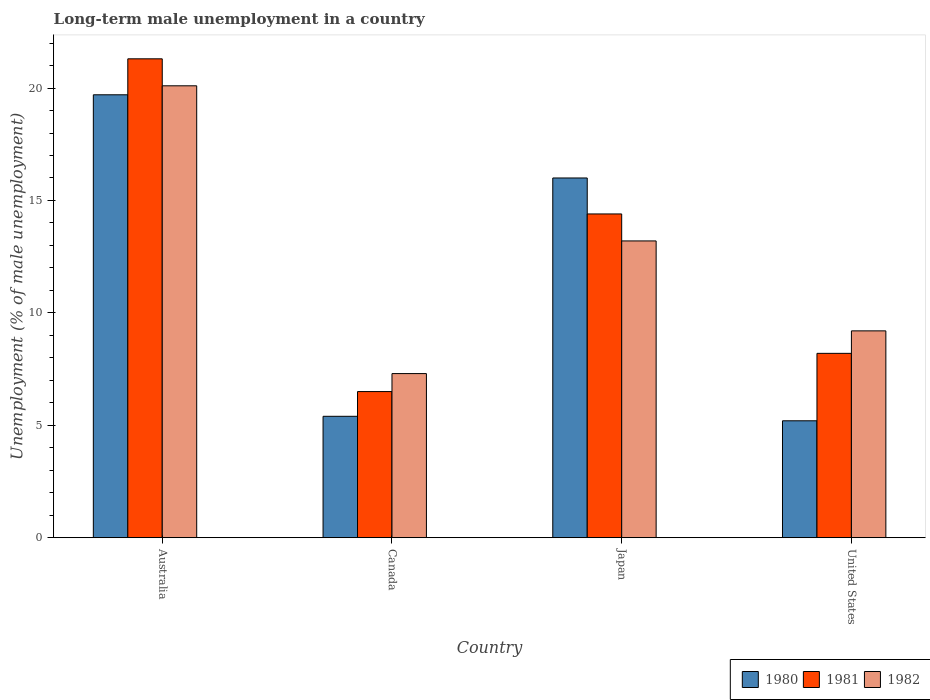Are the number of bars per tick equal to the number of legend labels?
Your answer should be very brief. Yes. How many bars are there on the 3rd tick from the left?
Give a very brief answer. 3. How many bars are there on the 4th tick from the right?
Your response must be concise. 3. What is the label of the 1st group of bars from the left?
Make the answer very short. Australia. What is the percentage of long-term unemployed male population in 1981 in Canada?
Keep it short and to the point. 6.5. Across all countries, what is the maximum percentage of long-term unemployed male population in 1981?
Offer a very short reply. 21.3. Across all countries, what is the minimum percentage of long-term unemployed male population in 1980?
Keep it short and to the point. 5.2. In which country was the percentage of long-term unemployed male population in 1982 minimum?
Offer a terse response. Canada. What is the total percentage of long-term unemployed male population in 1982 in the graph?
Provide a short and direct response. 49.8. What is the difference between the percentage of long-term unemployed male population in 1982 in Japan and that in United States?
Your answer should be very brief. 4. What is the difference between the percentage of long-term unemployed male population in 1982 in Japan and the percentage of long-term unemployed male population in 1981 in Australia?
Provide a short and direct response. -8.1. What is the average percentage of long-term unemployed male population in 1980 per country?
Provide a short and direct response. 11.58. What is the difference between the percentage of long-term unemployed male population of/in 1980 and percentage of long-term unemployed male population of/in 1981 in Australia?
Your response must be concise. -1.6. What is the ratio of the percentage of long-term unemployed male population in 1981 in Australia to that in Canada?
Your answer should be very brief. 3.28. What is the difference between the highest and the second highest percentage of long-term unemployed male population in 1981?
Keep it short and to the point. -13.1. What is the difference between the highest and the lowest percentage of long-term unemployed male population in 1981?
Offer a terse response. 14.8. Is it the case that in every country, the sum of the percentage of long-term unemployed male population in 1980 and percentage of long-term unemployed male population in 1981 is greater than the percentage of long-term unemployed male population in 1982?
Your answer should be very brief. Yes. Are the values on the major ticks of Y-axis written in scientific E-notation?
Your answer should be compact. No. Where does the legend appear in the graph?
Give a very brief answer. Bottom right. How many legend labels are there?
Provide a succinct answer. 3. How are the legend labels stacked?
Provide a short and direct response. Horizontal. What is the title of the graph?
Ensure brevity in your answer.  Long-term male unemployment in a country. Does "2000" appear as one of the legend labels in the graph?
Your answer should be very brief. No. What is the label or title of the X-axis?
Your answer should be compact. Country. What is the label or title of the Y-axis?
Give a very brief answer. Unemployment (% of male unemployment). What is the Unemployment (% of male unemployment) of 1980 in Australia?
Your answer should be very brief. 19.7. What is the Unemployment (% of male unemployment) of 1981 in Australia?
Your response must be concise. 21.3. What is the Unemployment (% of male unemployment) in 1982 in Australia?
Your answer should be very brief. 20.1. What is the Unemployment (% of male unemployment) of 1980 in Canada?
Give a very brief answer. 5.4. What is the Unemployment (% of male unemployment) in 1981 in Canada?
Make the answer very short. 6.5. What is the Unemployment (% of male unemployment) of 1982 in Canada?
Give a very brief answer. 7.3. What is the Unemployment (% of male unemployment) in 1981 in Japan?
Offer a very short reply. 14.4. What is the Unemployment (% of male unemployment) of 1982 in Japan?
Give a very brief answer. 13.2. What is the Unemployment (% of male unemployment) of 1980 in United States?
Your answer should be compact. 5.2. What is the Unemployment (% of male unemployment) in 1981 in United States?
Provide a short and direct response. 8.2. What is the Unemployment (% of male unemployment) of 1982 in United States?
Ensure brevity in your answer.  9.2. Across all countries, what is the maximum Unemployment (% of male unemployment) of 1980?
Ensure brevity in your answer.  19.7. Across all countries, what is the maximum Unemployment (% of male unemployment) of 1981?
Your answer should be compact. 21.3. Across all countries, what is the maximum Unemployment (% of male unemployment) in 1982?
Offer a terse response. 20.1. Across all countries, what is the minimum Unemployment (% of male unemployment) of 1980?
Provide a short and direct response. 5.2. Across all countries, what is the minimum Unemployment (% of male unemployment) of 1981?
Make the answer very short. 6.5. Across all countries, what is the minimum Unemployment (% of male unemployment) of 1982?
Make the answer very short. 7.3. What is the total Unemployment (% of male unemployment) of 1980 in the graph?
Ensure brevity in your answer.  46.3. What is the total Unemployment (% of male unemployment) of 1981 in the graph?
Make the answer very short. 50.4. What is the total Unemployment (% of male unemployment) of 1982 in the graph?
Your answer should be compact. 49.8. What is the difference between the Unemployment (% of male unemployment) of 1980 in Australia and that in Canada?
Your answer should be compact. 14.3. What is the difference between the Unemployment (% of male unemployment) in 1981 in Australia and that in Canada?
Your answer should be compact. 14.8. What is the difference between the Unemployment (% of male unemployment) in 1980 in Australia and that in Japan?
Provide a short and direct response. 3.7. What is the difference between the Unemployment (% of male unemployment) of 1981 in Australia and that in Japan?
Provide a short and direct response. 6.9. What is the difference between the Unemployment (% of male unemployment) in 1982 in Australia and that in United States?
Provide a succinct answer. 10.9. What is the difference between the Unemployment (% of male unemployment) of 1980 in Canada and that in United States?
Provide a short and direct response. 0.2. What is the difference between the Unemployment (% of male unemployment) in 1981 in Canada and that in United States?
Offer a very short reply. -1.7. What is the difference between the Unemployment (% of male unemployment) in 1981 in Japan and that in United States?
Make the answer very short. 6.2. What is the difference between the Unemployment (% of male unemployment) of 1982 in Japan and that in United States?
Offer a very short reply. 4. What is the difference between the Unemployment (% of male unemployment) of 1980 in Australia and the Unemployment (% of male unemployment) of 1981 in Canada?
Your answer should be compact. 13.2. What is the difference between the Unemployment (% of male unemployment) of 1981 in Australia and the Unemployment (% of male unemployment) of 1982 in Canada?
Offer a very short reply. 14. What is the difference between the Unemployment (% of male unemployment) in 1980 in Australia and the Unemployment (% of male unemployment) in 1981 in Japan?
Provide a short and direct response. 5.3. What is the difference between the Unemployment (% of male unemployment) in 1980 in Australia and the Unemployment (% of male unemployment) in 1982 in Japan?
Your response must be concise. 6.5. What is the difference between the Unemployment (% of male unemployment) in 1981 in Australia and the Unemployment (% of male unemployment) in 1982 in United States?
Make the answer very short. 12.1. What is the difference between the Unemployment (% of male unemployment) of 1980 in Canada and the Unemployment (% of male unemployment) of 1981 in Japan?
Your response must be concise. -9. What is the difference between the Unemployment (% of male unemployment) in 1981 in Canada and the Unemployment (% of male unemployment) in 1982 in Japan?
Your response must be concise. -6.7. What is the difference between the Unemployment (% of male unemployment) of 1980 in Canada and the Unemployment (% of male unemployment) of 1982 in United States?
Give a very brief answer. -3.8. What is the difference between the Unemployment (% of male unemployment) of 1980 in Japan and the Unemployment (% of male unemployment) of 1981 in United States?
Your response must be concise. 7.8. What is the difference between the Unemployment (% of male unemployment) of 1981 in Japan and the Unemployment (% of male unemployment) of 1982 in United States?
Your response must be concise. 5.2. What is the average Unemployment (% of male unemployment) of 1980 per country?
Provide a succinct answer. 11.57. What is the average Unemployment (% of male unemployment) in 1982 per country?
Offer a very short reply. 12.45. What is the difference between the Unemployment (% of male unemployment) in 1980 and Unemployment (% of male unemployment) in 1981 in Australia?
Offer a very short reply. -1.6. What is the difference between the Unemployment (% of male unemployment) of 1980 and Unemployment (% of male unemployment) of 1982 in Canada?
Keep it short and to the point. -1.9. What is the difference between the Unemployment (% of male unemployment) in 1980 and Unemployment (% of male unemployment) in 1981 in Japan?
Make the answer very short. 1.6. What is the ratio of the Unemployment (% of male unemployment) of 1980 in Australia to that in Canada?
Ensure brevity in your answer.  3.65. What is the ratio of the Unemployment (% of male unemployment) of 1981 in Australia to that in Canada?
Provide a succinct answer. 3.28. What is the ratio of the Unemployment (% of male unemployment) of 1982 in Australia to that in Canada?
Your answer should be very brief. 2.75. What is the ratio of the Unemployment (% of male unemployment) of 1980 in Australia to that in Japan?
Your response must be concise. 1.23. What is the ratio of the Unemployment (% of male unemployment) in 1981 in Australia to that in Japan?
Offer a very short reply. 1.48. What is the ratio of the Unemployment (% of male unemployment) in 1982 in Australia to that in Japan?
Your response must be concise. 1.52. What is the ratio of the Unemployment (% of male unemployment) of 1980 in Australia to that in United States?
Ensure brevity in your answer.  3.79. What is the ratio of the Unemployment (% of male unemployment) of 1981 in Australia to that in United States?
Your response must be concise. 2.6. What is the ratio of the Unemployment (% of male unemployment) in 1982 in Australia to that in United States?
Your response must be concise. 2.18. What is the ratio of the Unemployment (% of male unemployment) of 1980 in Canada to that in Japan?
Your answer should be very brief. 0.34. What is the ratio of the Unemployment (% of male unemployment) in 1981 in Canada to that in Japan?
Your answer should be very brief. 0.45. What is the ratio of the Unemployment (% of male unemployment) of 1982 in Canada to that in Japan?
Provide a succinct answer. 0.55. What is the ratio of the Unemployment (% of male unemployment) of 1981 in Canada to that in United States?
Offer a terse response. 0.79. What is the ratio of the Unemployment (% of male unemployment) in 1982 in Canada to that in United States?
Keep it short and to the point. 0.79. What is the ratio of the Unemployment (% of male unemployment) in 1980 in Japan to that in United States?
Offer a very short reply. 3.08. What is the ratio of the Unemployment (% of male unemployment) in 1981 in Japan to that in United States?
Ensure brevity in your answer.  1.76. What is the ratio of the Unemployment (% of male unemployment) of 1982 in Japan to that in United States?
Your response must be concise. 1.43. What is the difference between the highest and the second highest Unemployment (% of male unemployment) in 1980?
Offer a terse response. 3.7. What is the difference between the highest and the second highest Unemployment (% of male unemployment) in 1982?
Your answer should be very brief. 6.9. What is the difference between the highest and the lowest Unemployment (% of male unemployment) of 1980?
Make the answer very short. 14.5. What is the difference between the highest and the lowest Unemployment (% of male unemployment) of 1981?
Offer a very short reply. 14.8. 